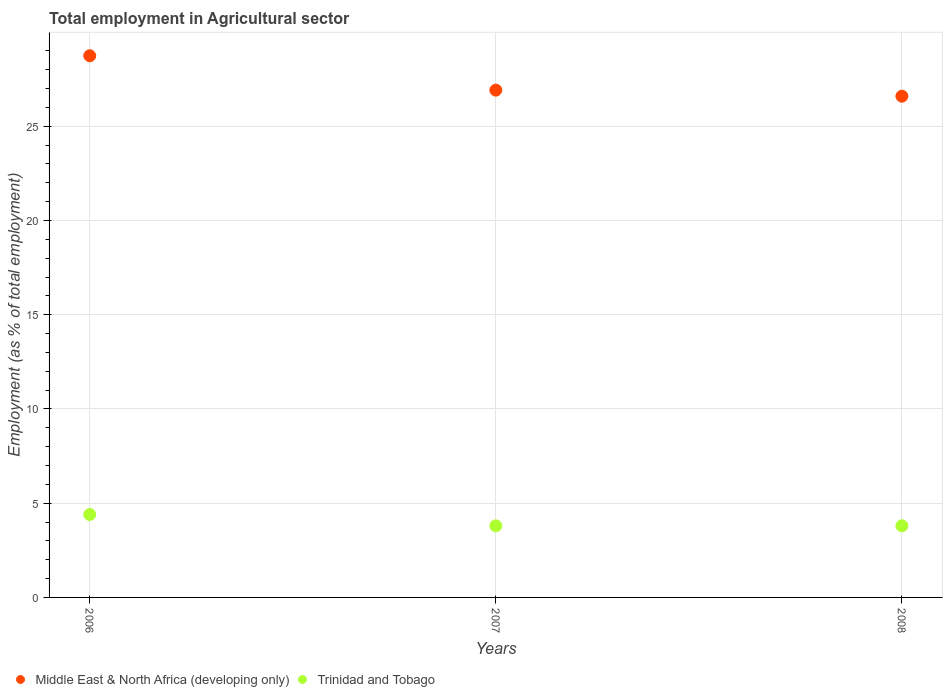How many different coloured dotlines are there?
Your response must be concise. 2. What is the employment in agricultural sector in Trinidad and Tobago in 2006?
Your answer should be compact. 4.4. Across all years, what is the maximum employment in agricultural sector in Trinidad and Tobago?
Your answer should be very brief. 4.4. Across all years, what is the minimum employment in agricultural sector in Middle East & North Africa (developing only)?
Your answer should be very brief. 26.6. In which year was the employment in agricultural sector in Trinidad and Tobago minimum?
Offer a terse response. 2007. What is the total employment in agricultural sector in Trinidad and Tobago in the graph?
Provide a short and direct response. 12. What is the difference between the employment in agricultural sector in Trinidad and Tobago in 2006 and that in 2008?
Your answer should be very brief. 0.6. What is the difference between the employment in agricultural sector in Middle East & North Africa (developing only) in 2006 and the employment in agricultural sector in Trinidad and Tobago in 2008?
Your answer should be very brief. 24.94. What is the average employment in agricultural sector in Middle East & North Africa (developing only) per year?
Provide a short and direct response. 27.42. In the year 2008, what is the difference between the employment in agricultural sector in Trinidad and Tobago and employment in agricultural sector in Middle East & North Africa (developing only)?
Provide a short and direct response. -22.8. What is the ratio of the employment in agricultural sector in Middle East & North Africa (developing only) in 2007 to that in 2008?
Provide a succinct answer. 1.01. What is the difference between the highest and the second highest employment in agricultural sector in Trinidad and Tobago?
Keep it short and to the point. 0.6. What is the difference between the highest and the lowest employment in agricultural sector in Trinidad and Tobago?
Provide a succinct answer. 0.6. Is the sum of the employment in agricultural sector in Trinidad and Tobago in 2006 and 2007 greater than the maximum employment in agricultural sector in Middle East & North Africa (developing only) across all years?
Ensure brevity in your answer.  No. Does the employment in agricultural sector in Middle East & North Africa (developing only) monotonically increase over the years?
Offer a terse response. No. Is the employment in agricultural sector in Trinidad and Tobago strictly greater than the employment in agricultural sector in Middle East & North Africa (developing only) over the years?
Provide a succinct answer. No. How many years are there in the graph?
Provide a succinct answer. 3. What is the difference between two consecutive major ticks on the Y-axis?
Give a very brief answer. 5. Does the graph contain any zero values?
Provide a succinct answer. No. Does the graph contain grids?
Make the answer very short. Yes. What is the title of the graph?
Offer a very short reply. Total employment in Agricultural sector. Does "French Polynesia" appear as one of the legend labels in the graph?
Give a very brief answer. No. What is the label or title of the Y-axis?
Your answer should be very brief. Employment (as % of total employment). What is the Employment (as % of total employment) in Middle East & North Africa (developing only) in 2006?
Provide a short and direct response. 28.74. What is the Employment (as % of total employment) of Trinidad and Tobago in 2006?
Provide a short and direct response. 4.4. What is the Employment (as % of total employment) of Middle East & North Africa (developing only) in 2007?
Give a very brief answer. 26.92. What is the Employment (as % of total employment) in Trinidad and Tobago in 2007?
Ensure brevity in your answer.  3.8. What is the Employment (as % of total employment) in Middle East & North Africa (developing only) in 2008?
Give a very brief answer. 26.6. What is the Employment (as % of total employment) of Trinidad and Tobago in 2008?
Provide a succinct answer. 3.8. Across all years, what is the maximum Employment (as % of total employment) in Middle East & North Africa (developing only)?
Keep it short and to the point. 28.74. Across all years, what is the maximum Employment (as % of total employment) in Trinidad and Tobago?
Keep it short and to the point. 4.4. Across all years, what is the minimum Employment (as % of total employment) of Middle East & North Africa (developing only)?
Provide a short and direct response. 26.6. Across all years, what is the minimum Employment (as % of total employment) of Trinidad and Tobago?
Ensure brevity in your answer.  3.8. What is the total Employment (as % of total employment) of Middle East & North Africa (developing only) in the graph?
Your response must be concise. 82.26. What is the difference between the Employment (as % of total employment) in Middle East & North Africa (developing only) in 2006 and that in 2007?
Your answer should be compact. 1.82. What is the difference between the Employment (as % of total employment) in Middle East & North Africa (developing only) in 2006 and that in 2008?
Your response must be concise. 2.15. What is the difference between the Employment (as % of total employment) in Trinidad and Tobago in 2006 and that in 2008?
Provide a succinct answer. 0.6. What is the difference between the Employment (as % of total employment) in Middle East & North Africa (developing only) in 2007 and that in 2008?
Provide a short and direct response. 0.32. What is the difference between the Employment (as % of total employment) in Middle East & North Africa (developing only) in 2006 and the Employment (as % of total employment) in Trinidad and Tobago in 2007?
Your answer should be very brief. 24.94. What is the difference between the Employment (as % of total employment) of Middle East & North Africa (developing only) in 2006 and the Employment (as % of total employment) of Trinidad and Tobago in 2008?
Provide a succinct answer. 24.94. What is the difference between the Employment (as % of total employment) of Middle East & North Africa (developing only) in 2007 and the Employment (as % of total employment) of Trinidad and Tobago in 2008?
Ensure brevity in your answer.  23.12. What is the average Employment (as % of total employment) in Middle East & North Africa (developing only) per year?
Your answer should be compact. 27.42. What is the average Employment (as % of total employment) of Trinidad and Tobago per year?
Your answer should be very brief. 4. In the year 2006, what is the difference between the Employment (as % of total employment) of Middle East & North Africa (developing only) and Employment (as % of total employment) of Trinidad and Tobago?
Your answer should be compact. 24.34. In the year 2007, what is the difference between the Employment (as % of total employment) of Middle East & North Africa (developing only) and Employment (as % of total employment) of Trinidad and Tobago?
Your response must be concise. 23.12. In the year 2008, what is the difference between the Employment (as % of total employment) of Middle East & North Africa (developing only) and Employment (as % of total employment) of Trinidad and Tobago?
Give a very brief answer. 22.8. What is the ratio of the Employment (as % of total employment) in Middle East & North Africa (developing only) in 2006 to that in 2007?
Your response must be concise. 1.07. What is the ratio of the Employment (as % of total employment) of Trinidad and Tobago in 2006 to that in 2007?
Offer a terse response. 1.16. What is the ratio of the Employment (as % of total employment) in Middle East & North Africa (developing only) in 2006 to that in 2008?
Provide a succinct answer. 1.08. What is the ratio of the Employment (as % of total employment) of Trinidad and Tobago in 2006 to that in 2008?
Give a very brief answer. 1.16. What is the ratio of the Employment (as % of total employment) of Middle East & North Africa (developing only) in 2007 to that in 2008?
Your answer should be compact. 1.01. What is the ratio of the Employment (as % of total employment) of Trinidad and Tobago in 2007 to that in 2008?
Your response must be concise. 1. What is the difference between the highest and the second highest Employment (as % of total employment) in Middle East & North Africa (developing only)?
Your response must be concise. 1.82. What is the difference between the highest and the second highest Employment (as % of total employment) in Trinidad and Tobago?
Your response must be concise. 0.6. What is the difference between the highest and the lowest Employment (as % of total employment) of Middle East & North Africa (developing only)?
Your answer should be very brief. 2.15. 